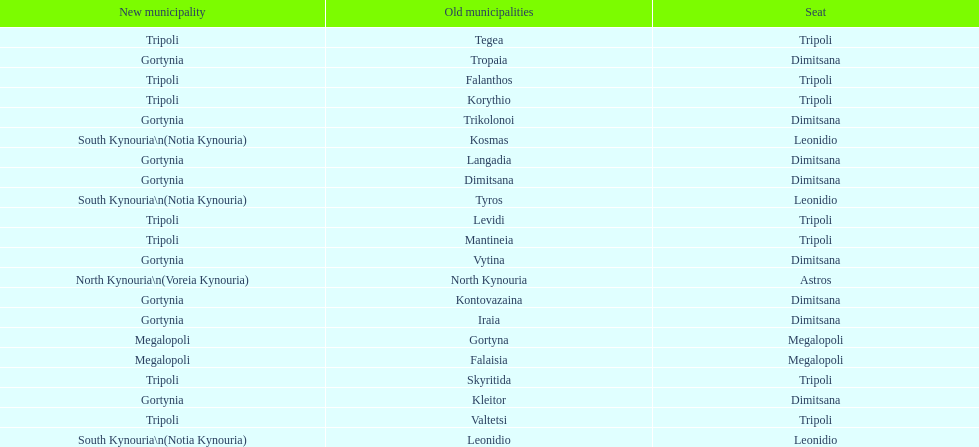Is tripoli still considered a municipality in arcadia since its 2011 reformation? Yes. 